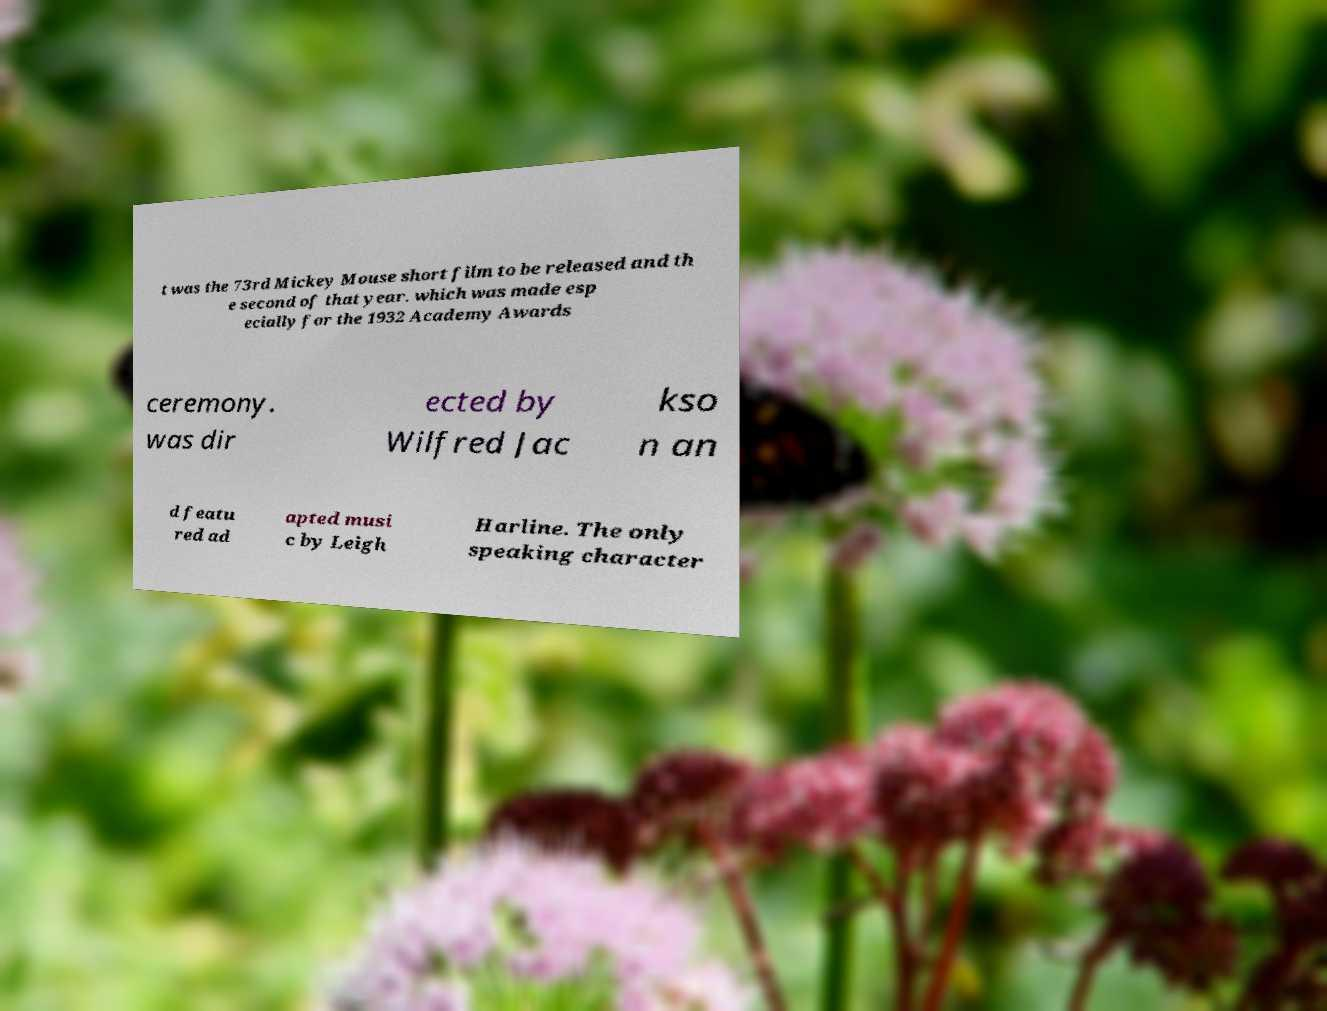There's text embedded in this image that I need extracted. Can you transcribe it verbatim? t was the 73rd Mickey Mouse short film to be released and th e second of that year. which was made esp ecially for the 1932 Academy Awards ceremony. was dir ected by Wilfred Jac kso n an d featu red ad apted musi c by Leigh Harline. The only speaking character 